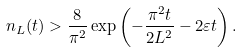Convert formula to latex. <formula><loc_0><loc_0><loc_500><loc_500>n _ { L } ( t ) > \frac { 8 } { \pi ^ { 2 } } \exp \left ( - \frac { \pi ^ { 2 } t } { 2 L ^ { 2 } } - 2 \varepsilon t \right ) .</formula> 